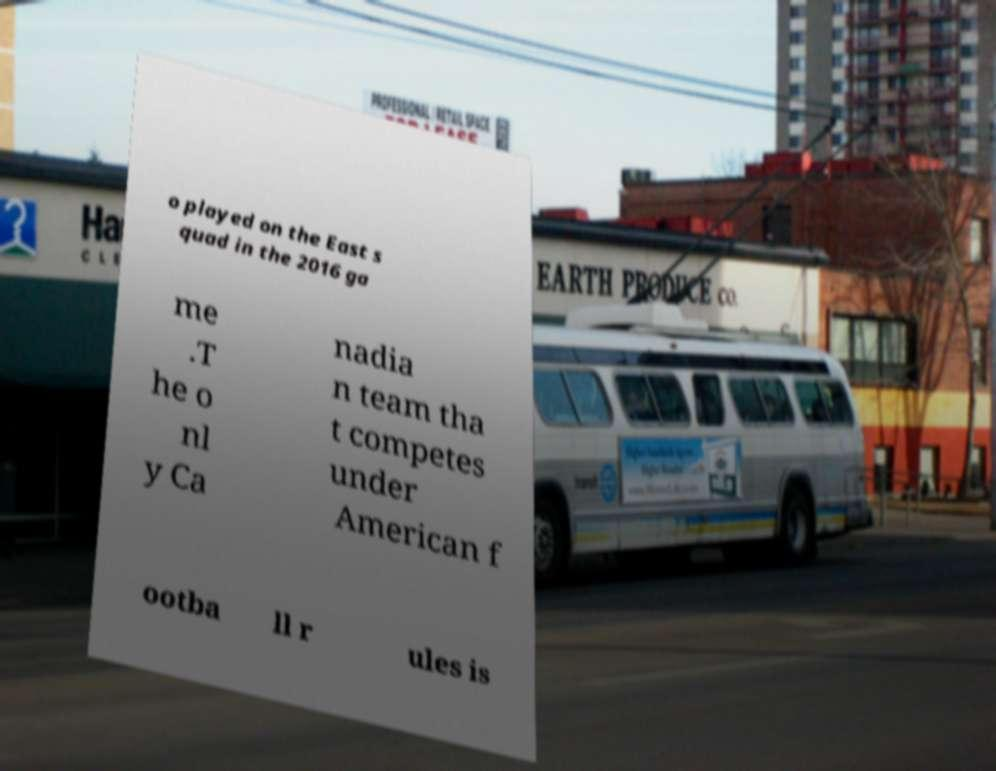I need the written content from this picture converted into text. Can you do that? o played on the East s quad in the 2016 ga me .T he o nl y Ca nadia n team tha t competes under American f ootba ll r ules is 